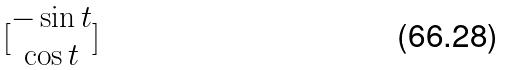Convert formula to latex. <formula><loc_0><loc_0><loc_500><loc_500>[ \begin{matrix} - \sin t \\ \cos t \end{matrix} ]</formula> 